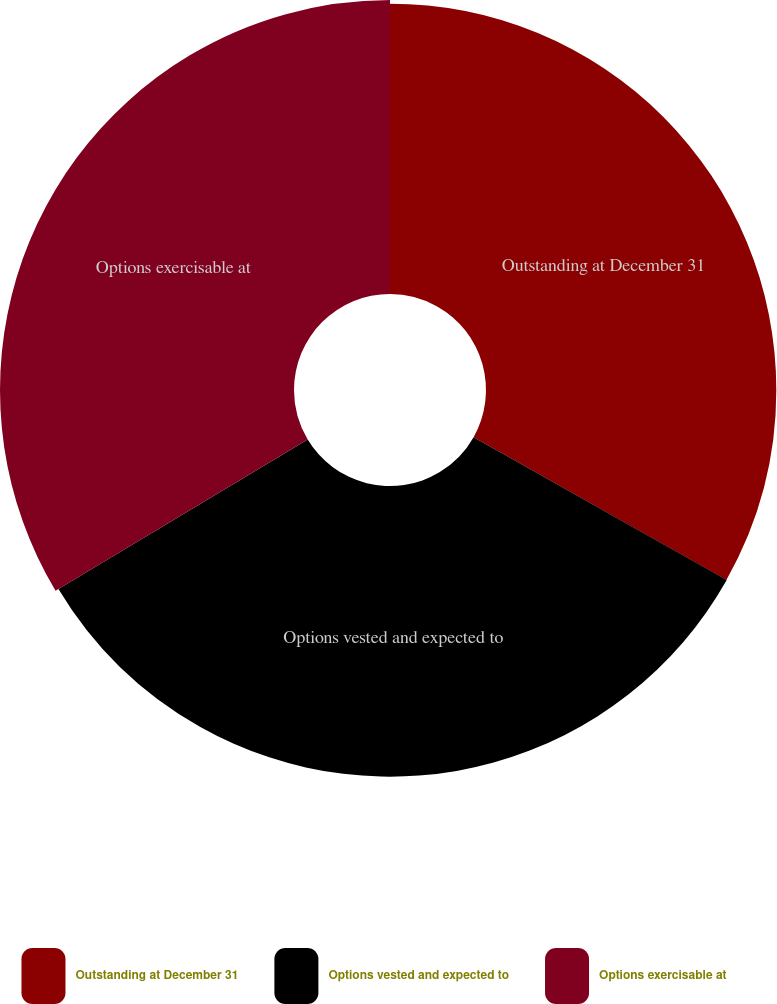Convert chart. <chart><loc_0><loc_0><loc_500><loc_500><pie_chart><fcel>Outstanding at December 31<fcel>Options vested and expected to<fcel>Options exercisable at<nl><fcel>33.18%<fcel>33.22%<fcel>33.6%<nl></chart> 